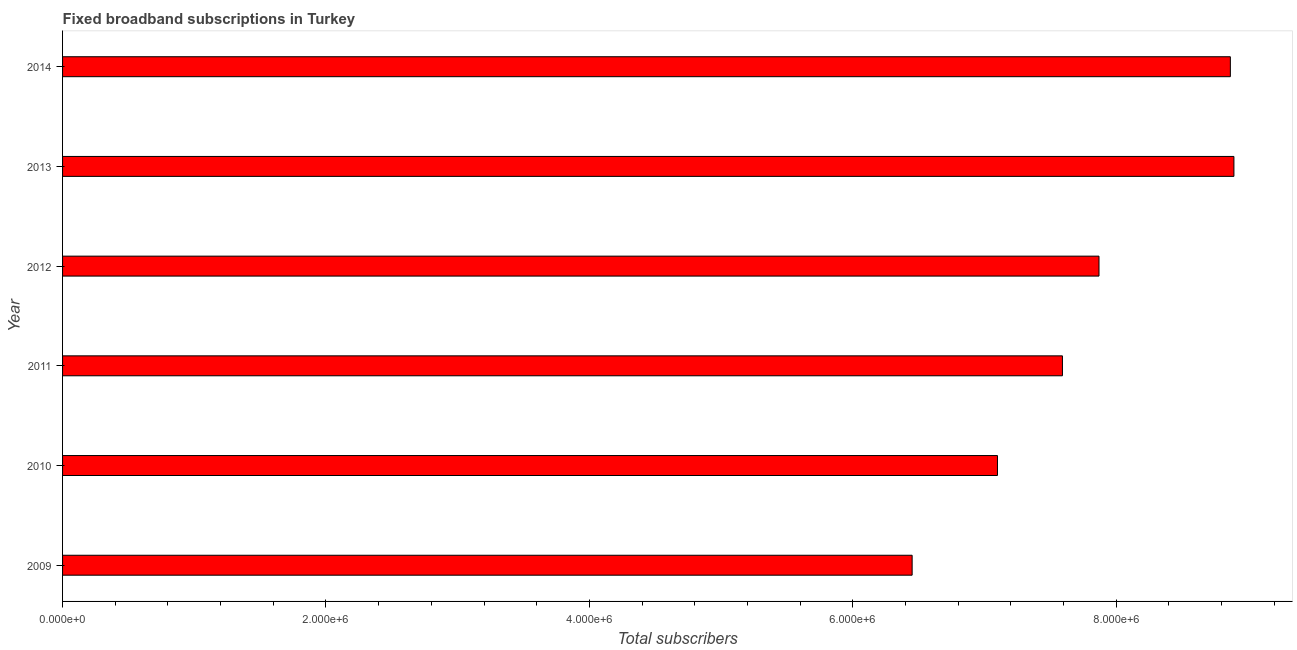What is the title of the graph?
Your answer should be very brief. Fixed broadband subscriptions in Turkey. What is the label or title of the X-axis?
Keep it short and to the point. Total subscribers. What is the total number of fixed broadband subscriptions in 2014?
Your answer should be compact. 8.87e+06. Across all years, what is the maximum total number of fixed broadband subscriptions?
Give a very brief answer. 8.89e+06. Across all years, what is the minimum total number of fixed broadband subscriptions?
Offer a terse response. 6.45e+06. In which year was the total number of fixed broadband subscriptions maximum?
Ensure brevity in your answer.  2013. In which year was the total number of fixed broadband subscriptions minimum?
Offer a terse response. 2009. What is the sum of the total number of fixed broadband subscriptions?
Keep it short and to the point. 4.68e+07. What is the difference between the total number of fixed broadband subscriptions in 2010 and 2012?
Ensure brevity in your answer.  -7.71e+05. What is the average total number of fixed broadband subscriptions per year?
Your answer should be very brief. 7.79e+06. What is the median total number of fixed broadband subscriptions?
Give a very brief answer. 7.73e+06. In how many years, is the total number of fixed broadband subscriptions greater than 2800000 ?
Your answer should be compact. 6. Do a majority of the years between 2010 and 2012 (inclusive) have total number of fixed broadband subscriptions greater than 4000000 ?
Provide a succinct answer. Yes. What is the ratio of the total number of fixed broadband subscriptions in 2009 to that in 2010?
Your response must be concise. 0.91. What is the difference between the highest and the second highest total number of fixed broadband subscriptions?
Give a very brief answer. 2.70e+04. What is the difference between the highest and the lowest total number of fixed broadband subscriptions?
Provide a short and direct response. 2.44e+06. Are all the bars in the graph horizontal?
Your answer should be very brief. Yes. What is the Total subscribers in 2009?
Offer a terse response. 6.45e+06. What is the Total subscribers in 2010?
Make the answer very short. 7.10e+06. What is the Total subscribers of 2011?
Ensure brevity in your answer.  7.59e+06. What is the Total subscribers of 2012?
Provide a short and direct response. 7.87e+06. What is the Total subscribers of 2013?
Offer a terse response. 8.89e+06. What is the Total subscribers of 2014?
Offer a terse response. 8.87e+06. What is the difference between the Total subscribers in 2009 and 2010?
Ensure brevity in your answer.  -6.48e+05. What is the difference between the Total subscribers in 2009 and 2011?
Make the answer very short. -1.14e+06. What is the difference between the Total subscribers in 2009 and 2012?
Provide a succinct answer. -1.42e+06. What is the difference between the Total subscribers in 2009 and 2013?
Ensure brevity in your answer.  -2.44e+06. What is the difference between the Total subscribers in 2009 and 2014?
Your response must be concise. -2.42e+06. What is the difference between the Total subscribers in 2010 and 2011?
Provide a succinct answer. -4.93e+05. What is the difference between the Total subscribers in 2010 and 2012?
Your answer should be very brief. -7.71e+05. What is the difference between the Total subscribers in 2010 and 2013?
Offer a very short reply. -1.80e+06. What is the difference between the Total subscribers in 2010 and 2014?
Give a very brief answer. -1.77e+06. What is the difference between the Total subscribers in 2011 and 2012?
Your answer should be very brief. -2.78e+05. What is the difference between the Total subscribers in 2011 and 2013?
Your answer should be compact. -1.30e+06. What is the difference between the Total subscribers in 2011 and 2014?
Provide a succinct answer. -1.27e+06. What is the difference between the Total subscribers in 2012 and 2013?
Keep it short and to the point. -1.02e+06. What is the difference between the Total subscribers in 2012 and 2014?
Offer a terse response. -9.97e+05. What is the difference between the Total subscribers in 2013 and 2014?
Offer a terse response. 2.70e+04. What is the ratio of the Total subscribers in 2009 to that in 2010?
Make the answer very short. 0.91. What is the ratio of the Total subscribers in 2009 to that in 2011?
Your answer should be very brief. 0.85. What is the ratio of the Total subscribers in 2009 to that in 2012?
Your answer should be very brief. 0.82. What is the ratio of the Total subscribers in 2009 to that in 2013?
Your answer should be very brief. 0.72. What is the ratio of the Total subscribers in 2009 to that in 2014?
Offer a terse response. 0.73. What is the ratio of the Total subscribers in 2010 to that in 2011?
Provide a short and direct response. 0.94. What is the ratio of the Total subscribers in 2010 to that in 2012?
Your response must be concise. 0.9. What is the ratio of the Total subscribers in 2010 to that in 2013?
Your response must be concise. 0.8. What is the ratio of the Total subscribers in 2010 to that in 2014?
Ensure brevity in your answer.  0.8. What is the ratio of the Total subscribers in 2011 to that in 2012?
Offer a very short reply. 0.96. What is the ratio of the Total subscribers in 2011 to that in 2013?
Provide a succinct answer. 0.85. What is the ratio of the Total subscribers in 2011 to that in 2014?
Make the answer very short. 0.86. What is the ratio of the Total subscribers in 2012 to that in 2013?
Your response must be concise. 0.89. What is the ratio of the Total subscribers in 2012 to that in 2014?
Provide a short and direct response. 0.89. 